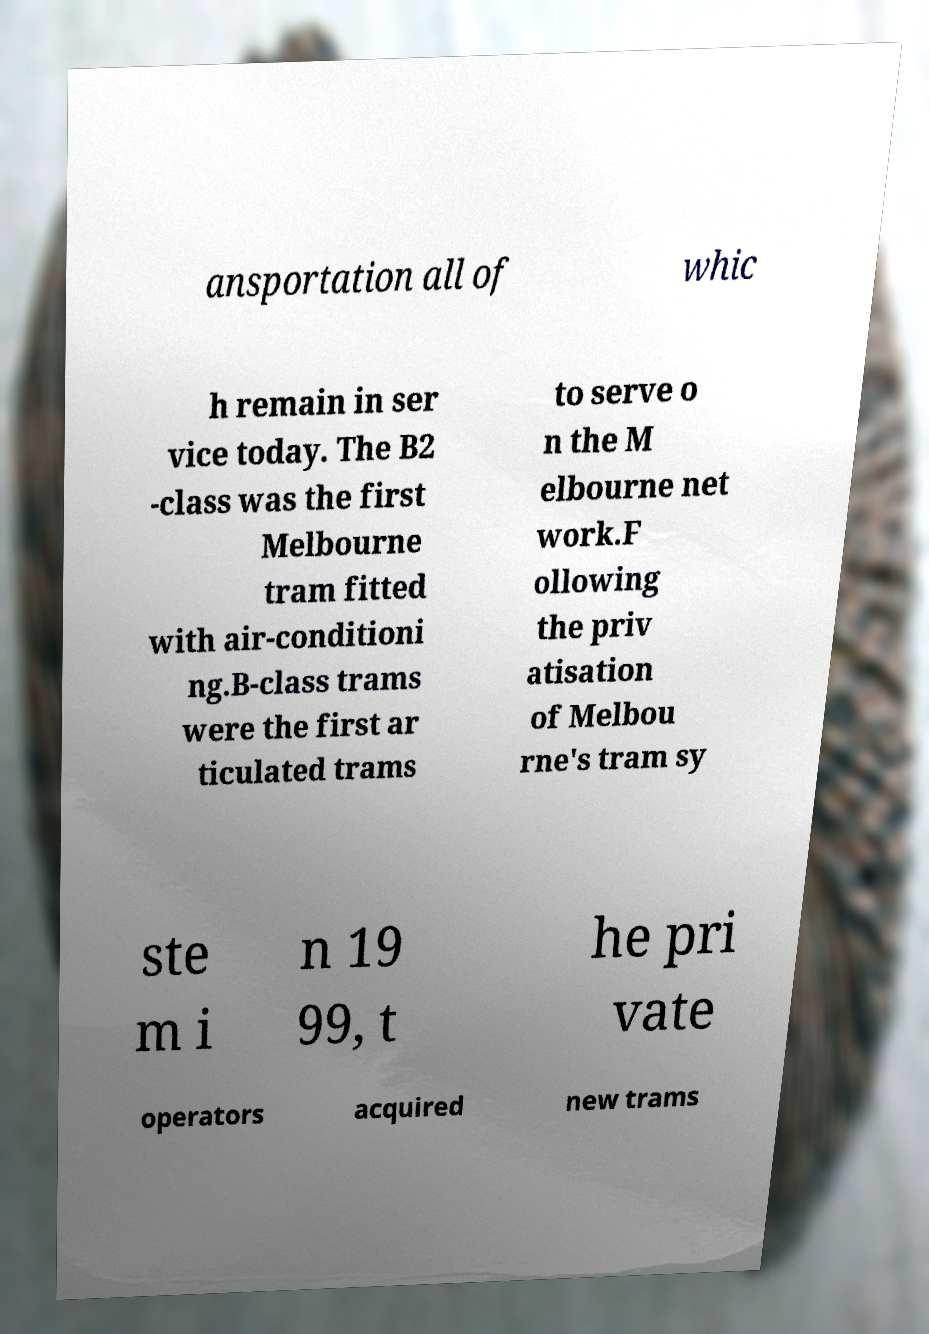There's text embedded in this image that I need extracted. Can you transcribe it verbatim? ansportation all of whic h remain in ser vice today. The B2 -class was the first Melbourne tram fitted with air-conditioni ng.B-class trams were the first ar ticulated trams to serve o n the M elbourne net work.F ollowing the priv atisation of Melbou rne's tram sy ste m i n 19 99, t he pri vate operators acquired new trams 